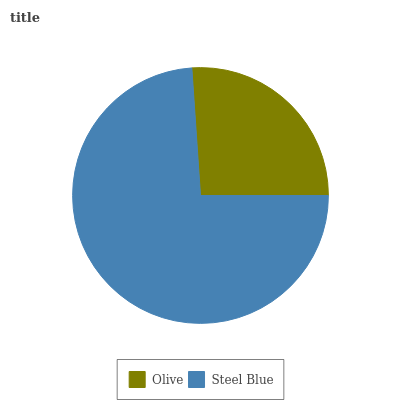Is Olive the minimum?
Answer yes or no. Yes. Is Steel Blue the maximum?
Answer yes or no. Yes. Is Steel Blue the minimum?
Answer yes or no. No. Is Steel Blue greater than Olive?
Answer yes or no. Yes. Is Olive less than Steel Blue?
Answer yes or no. Yes. Is Olive greater than Steel Blue?
Answer yes or no. No. Is Steel Blue less than Olive?
Answer yes or no. No. Is Steel Blue the high median?
Answer yes or no. Yes. Is Olive the low median?
Answer yes or no. Yes. Is Olive the high median?
Answer yes or no. No. Is Steel Blue the low median?
Answer yes or no. No. 